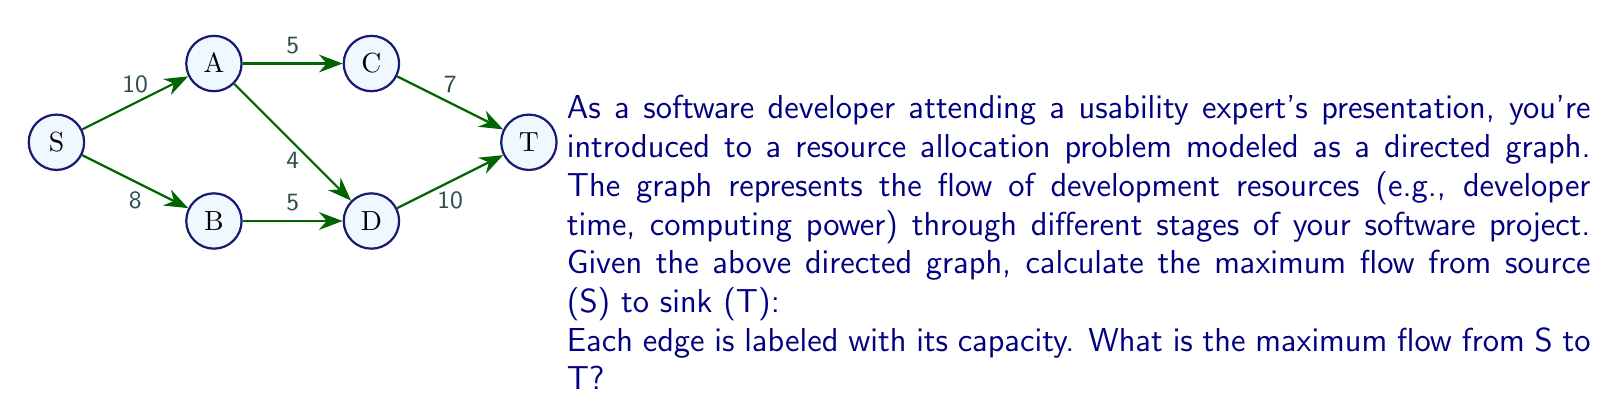Help me with this question. To solve this maximum flow problem, we'll use the Ford-Fulkerson algorithm:

1) Initialize flow to 0 for all edges.

2) Find an augmenting path from S to T:
   Path 1: S -> A -> C -> T (min capacity = 5)
   Update flow:
   $f(S,A) = 5$, $f(A,C) = 5$, $f(C,T) = 5$
   Residual capacities:
   $c_f(S,A) = 5$, $c_f(A,C) = 0$, $c_f(C,T) = 2$

3) Find another augmenting path:
   Path 2: S -> A -> D -> T (min capacity = 4)
   Update flow:
   $f(S,A) = 9$, $f(A,D) = 4$, $f(D,T) = 4$
   Residual capacities:
   $c_f(S,A) = 1$, $c_f(A,D) = 0$, $c_f(D,T) = 6$

4) Find another augmenting path:
   Path 3: S -> B -> D -> T (min capacity = 5)
   Update flow:
   $f(S,B) = 5$, $f(B,D) = 5$, $f(D,T) = 9$
   Residual capacities:
   $c_f(S,B) = 3$, $c_f(B,D) = 0$, $c_f(D,T) = 1$

5) Find another augmenting path:
   Path 4: S -> B -> D -> T (min capacity = 1)
   Update flow:
   $f(S,B) = 6$, $f(B,D) = 6$, $f(D,T) = 10$
   Residual capacities:
   $c_f(S,B) = 2$, $c_f(B,D) = 0$, $c_f(D,T) = 0$

No more augmenting paths exist. The maximum flow is the sum of all flows into T:
$$\text{Max Flow} = f(C,T) + f(D,T) = 5 + 10 = 15$$
Answer: 15 